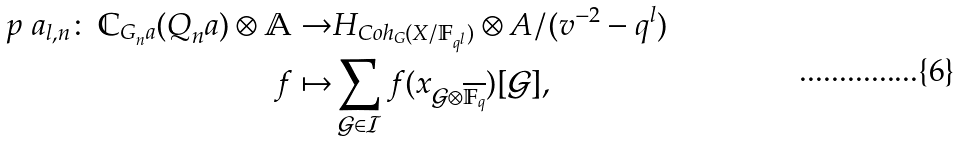Convert formula to latex. <formula><loc_0><loc_0><loc_500><loc_500>p ^ { \ } a _ { l , n } \colon \, \mathbb { C } _ { G _ { n } ^ { \ } a } ( Q _ { n } ^ { \ } a ) \otimes \mathbb { A } \to & H _ { C o h _ { G } ( X / \mathbb { F } _ { q ^ { l } } ) } \otimes A / ( v ^ { - 2 } - q ^ { l } ) \\ f \mapsto & \sum _ { \mathcal { G } \in \mathcal { I } } f ( x _ { \mathcal { G } \otimes \overline { \mathbb { F } _ { q } } } ) [ \mathcal { G } ] ,</formula> 